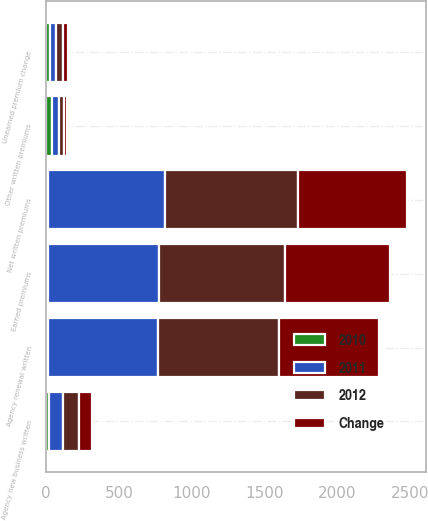<chart> <loc_0><loc_0><loc_500><loc_500><stacked_bar_chart><ecel><fcel>Agency renewal written<fcel>Agency new business written<fcel>Other written premiums<fcel>Net written premiums<fcel>Unearned premium change<fcel>Earned premiums<nl><fcel>2012<fcel>836<fcel>111<fcel>29<fcel>918<fcel>50<fcel>868<nl><fcel>2011<fcel>755<fcel>95<fcel>49<fcel>801<fcel>39<fcel>762<nl><fcel>Change<fcel>685<fcel>90<fcel>25<fcel>750<fcel>29<fcel>721<nl><fcel>2010<fcel>11<fcel>17<fcel>41<fcel>15<fcel>28<fcel>14<nl></chart> 